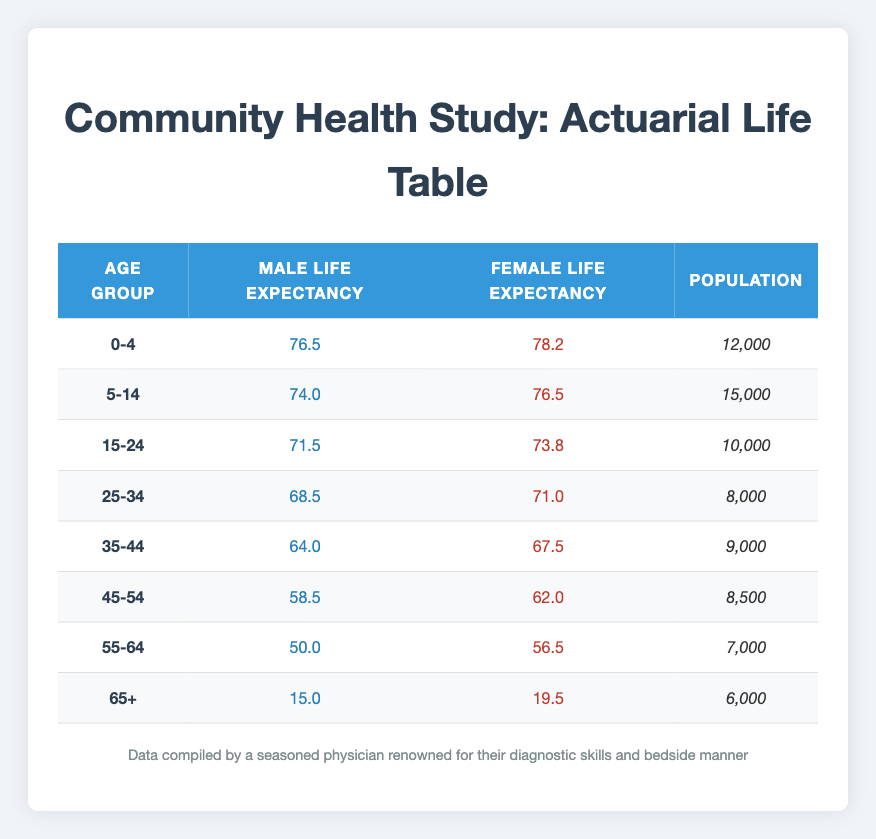What is the male life expectancy for the age group 25-34? In the table, we can find the age group 25-34 and look at the corresponding male life expectancy value, which is 68.5.
Answer: 68.5 What is the population count for the age group 55-64? Referring to the row for age group 55-64, the population is stated as 7,000.
Answer: 7,000 Which age group has the highest female life expectancy? To identify this, we need to compare the female life expectancy values across all age groups. The highest value is 78.2 for the age group 0-4.
Answer: 0-4 Is the male life expectancy for the age group 45-54 greater than that for the age group 35-44? The male life expectancy for age group 45-54 is 58.5, and for age group 35-44 it is 64.0. Since 58.5 < 64.0, the statement is false.
Answer: No What is the average female life expectancy across all age groups? First, we need to sum the female life expectancy values: 78.2 + 76.5 + 73.8 + 71.0 + 67.5 + 62.0 + 56.5 + 19.5 =  495.0. Then, divide by the number of age groups, which is 8. Therefore, the average is 495.0 / 8 = 61.875.
Answer: 61.875 How many males are in the age group 65+ compared to the age group 0-4? The population for age group 65+ is 6,000 and for age group 0-4 it is 12,000. Since 6,000 < 12,000, there are fewer males in the age group 65+.
Answer: Yes Which age group has the lowest female life expectancy? By reviewing the table, we find that the greatest female life expectancy is 78.2 for ages 0-4, while the lowest value is 19.5 for ages 65+.
Answer: 65+ What is the difference in male life expectancy between age groups 15-24 and 5-14? The male life expectancy for age group 15-24 is 71.5 and for 5-14 is 74.0. Thus, the difference is 74.0 - 71.5 = 2.5.
Answer: 2.5 What is the total population of the age group 35-54? To find the total population, we add the populations of age groups 35-44 (9,000) and 45-54 (8,500). Therefore, the total is 9,000 + 8,500 = 17,500.
Answer: 17,500 